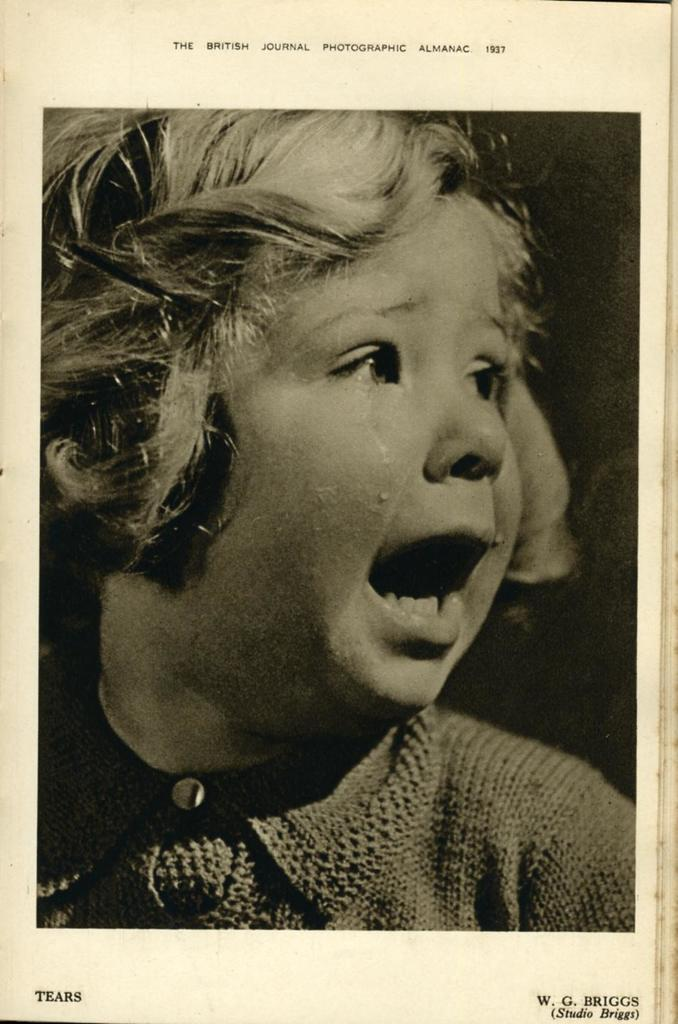Who is the main subject in the picture? There is a girl in the picture. What is the girl wearing? The girl is wearing a t-shirt. How is the girl feeling in the image? The girl is crying. What type of publication might this image be associated with? The image appears to be a book cover. Who is the author of the book? The author's name is visible at the bottom of the image. What is the content of the book? The content is visible at the top of the image. What type of afternoon activity is the girl participating in, as depicted in the image? The image does not show any specific afternoon activity; it only shows the girl crying. 